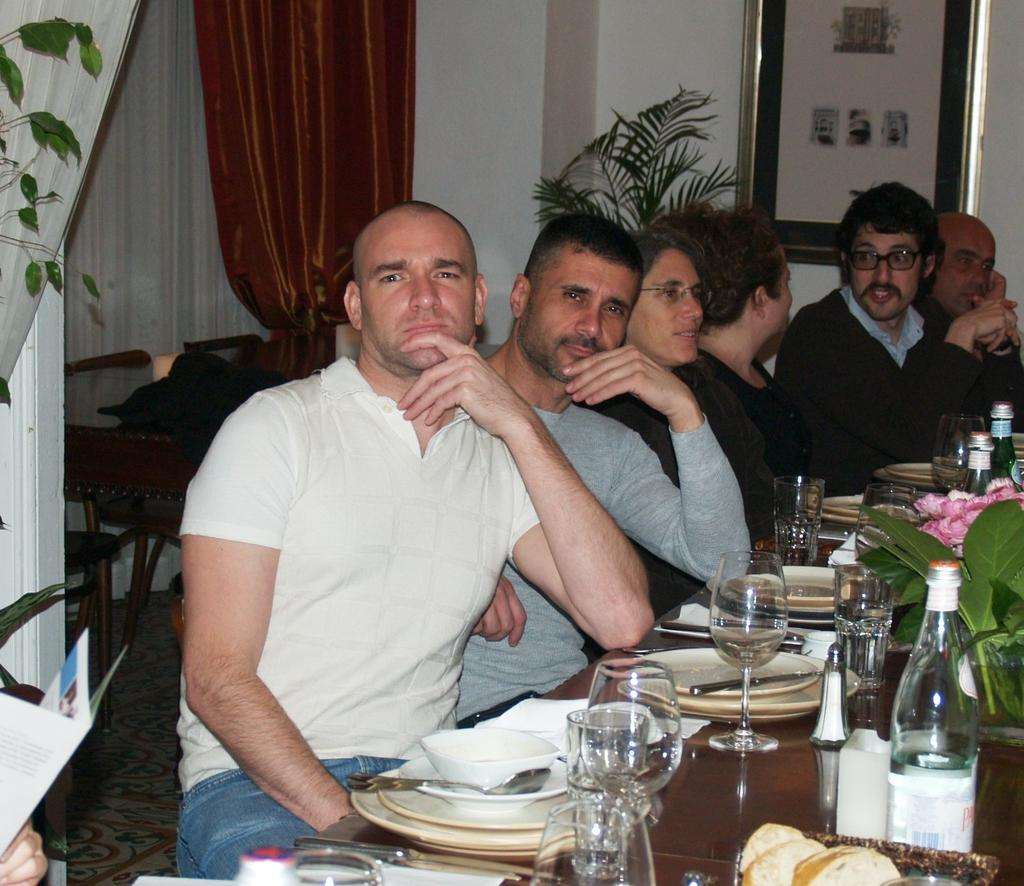What type of structure can be seen in the image? There is a wall in the image. What decorative item is present on the wall? There is a photo frame in the image. What type of window treatment is visible in the image? There is a curtain in the image. What are the people in the image doing? There are people sitting on chairs in the image. What type of furniture is present in the image? There are tables in the image. What items can be seen on the tables? There are plates, bowls, and bottles on the tables. What type of stomach ailment is the person experiencing in the image? There is no indication of any stomach ailment or person experiencing discomfort in the image. Where is the wilderness setting in the image? There is no wilderness setting present in the image; it features a room with tables, chairs, and people. 